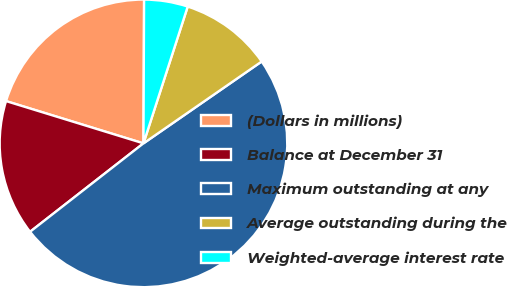<chart> <loc_0><loc_0><loc_500><loc_500><pie_chart><fcel>(Dollars in millions)<fcel>Balance at December 31<fcel>Maximum outstanding at any<fcel>Average outstanding during the<fcel>Weighted-average interest rate<nl><fcel>20.32%<fcel>15.29%<fcel>49.1%<fcel>10.38%<fcel>4.91%<nl></chart> 